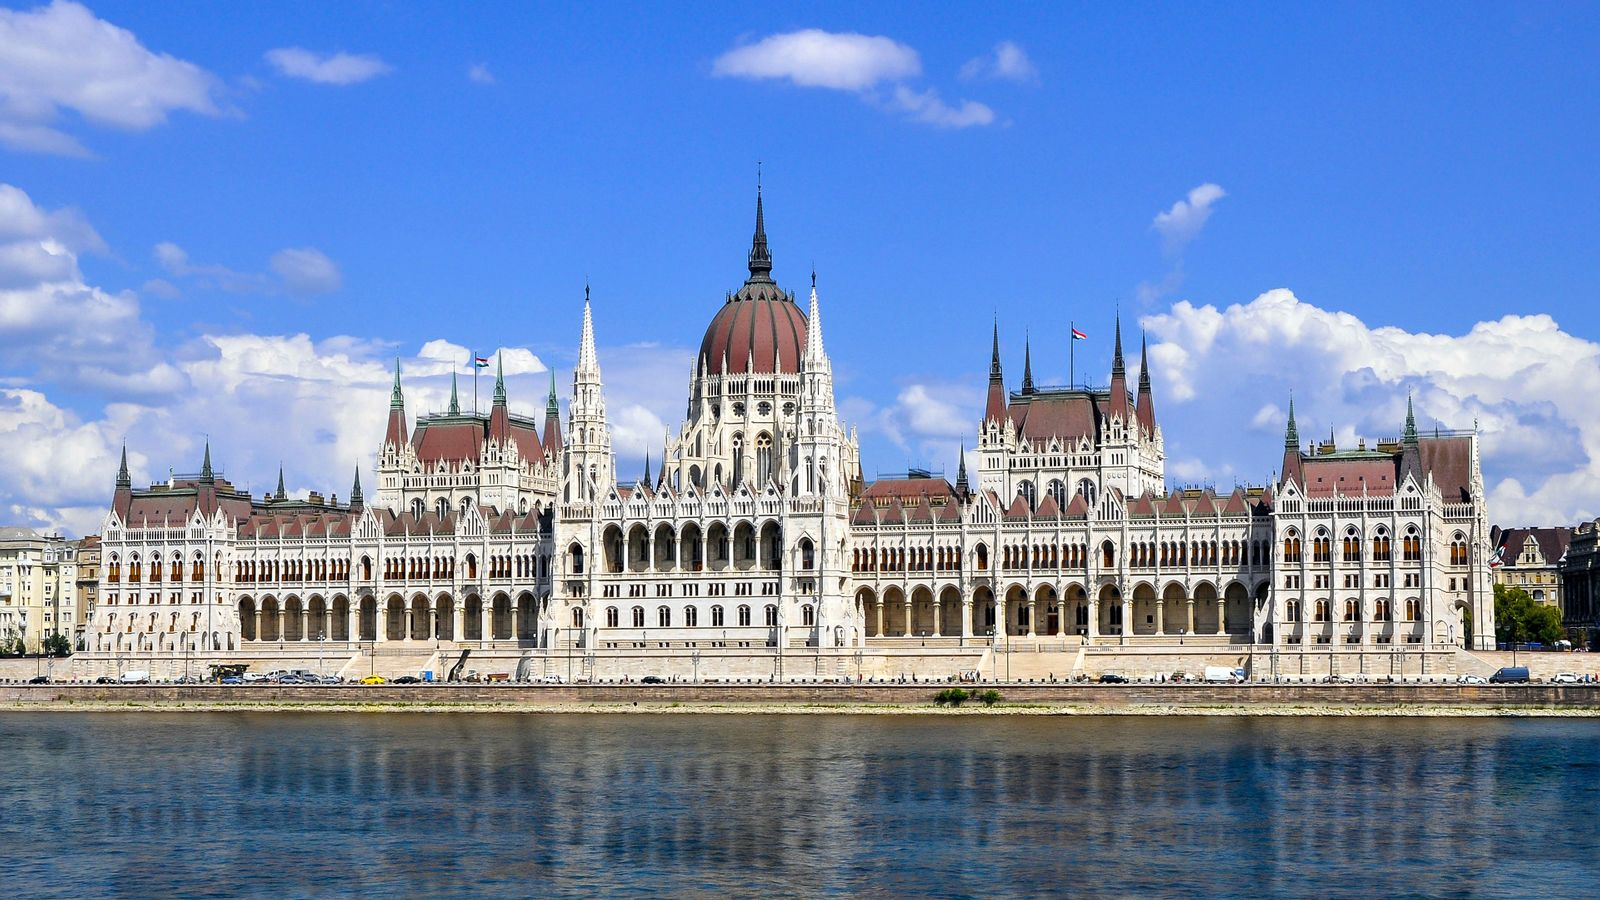What emotions does this scene evoke in you? This scene evokes a deep emotional response, blending awe and tranquility. The grandeur of the Hungarian Parliament Building, with its intricate design and historical significance, instills a sense of admiration and wonder. The serene setting along the Danube River, under a clear blue sky, creates a feeling of peace and relaxation. The combination of natural beauty and architectural excellence invites contemplation and appreciation of the cultural heritage and the timeless beauty of Budapest. It's a moment that makes one feel connected to history, inspired by human creativity, and soothed by the harmonious landscape. 